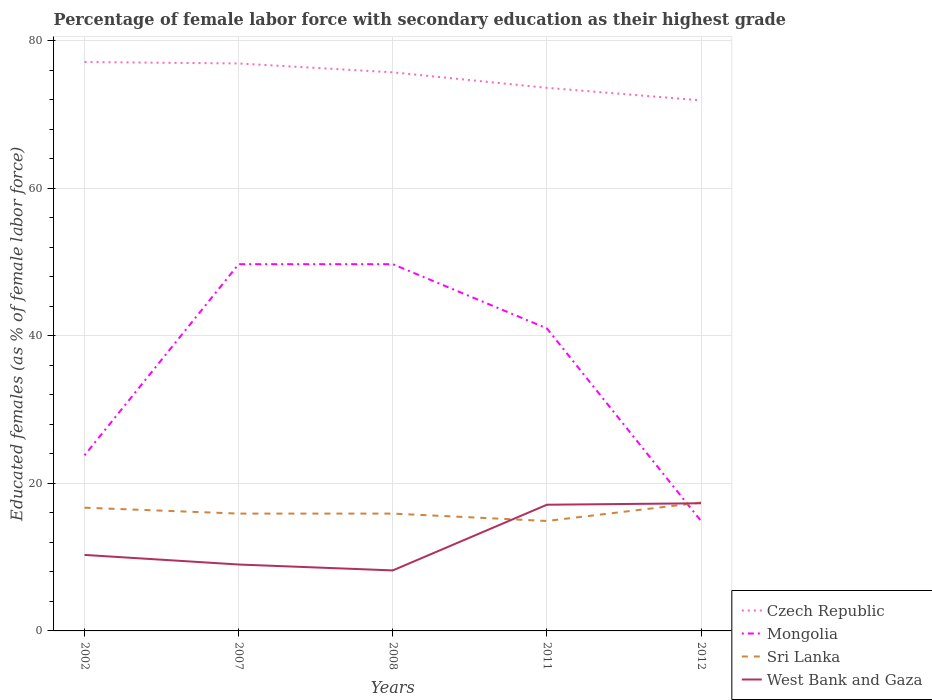Does the line corresponding to West Bank and Gaza intersect with the line corresponding to Mongolia?
Provide a short and direct response. Yes. Is the number of lines equal to the number of legend labels?
Make the answer very short. Yes. Across all years, what is the maximum percentage of female labor force with secondary education in Sri Lanka?
Offer a very short reply. 14.9. What is the total percentage of female labor force with secondary education in Mongolia in the graph?
Your response must be concise. 34.8. What is the difference between the highest and the second highest percentage of female labor force with secondary education in Mongolia?
Ensure brevity in your answer.  34.8. What is the difference between the highest and the lowest percentage of female labor force with secondary education in Mongolia?
Offer a terse response. 3. What is the difference between two consecutive major ticks on the Y-axis?
Keep it short and to the point. 20. Are the values on the major ticks of Y-axis written in scientific E-notation?
Give a very brief answer. No. Does the graph contain any zero values?
Keep it short and to the point. No. Does the graph contain grids?
Your answer should be compact. Yes. How are the legend labels stacked?
Your answer should be very brief. Vertical. What is the title of the graph?
Keep it short and to the point. Percentage of female labor force with secondary education as their highest grade. What is the label or title of the Y-axis?
Provide a short and direct response. Educated females (as % of female labor force). What is the Educated females (as % of female labor force) of Czech Republic in 2002?
Offer a terse response. 77.1. What is the Educated females (as % of female labor force) in Mongolia in 2002?
Offer a very short reply. 23.8. What is the Educated females (as % of female labor force) in Sri Lanka in 2002?
Offer a very short reply. 16.7. What is the Educated females (as % of female labor force) in West Bank and Gaza in 2002?
Keep it short and to the point. 10.3. What is the Educated females (as % of female labor force) in Czech Republic in 2007?
Offer a terse response. 76.9. What is the Educated females (as % of female labor force) in Mongolia in 2007?
Give a very brief answer. 49.7. What is the Educated females (as % of female labor force) in Sri Lanka in 2007?
Make the answer very short. 15.9. What is the Educated females (as % of female labor force) of West Bank and Gaza in 2007?
Your response must be concise. 9. What is the Educated females (as % of female labor force) of Czech Republic in 2008?
Give a very brief answer. 75.7. What is the Educated females (as % of female labor force) of Mongolia in 2008?
Your response must be concise. 49.7. What is the Educated females (as % of female labor force) of Sri Lanka in 2008?
Make the answer very short. 15.9. What is the Educated females (as % of female labor force) in West Bank and Gaza in 2008?
Provide a succinct answer. 8.2. What is the Educated females (as % of female labor force) of Czech Republic in 2011?
Your answer should be compact. 73.6. What is the Educated females (as % of female labor force) of Mongolia in 2011?
Your answer should be compact. 41. What is the Educated females (as % of female labor force) of Sri Lanka in 2011?
Ensure brevity in your answer.  14.9. What is the Educated females (as % of female labor force) in West Bank and Gaza in 2011?
Ensure brevity in your answer.  17.1. What is the Educated females (as % of female labor force) of Czech Republic in 2012?
Make the answer very short. 71.9. What is the Educated females (as % of female labor force) in Mongolia in 2012?
Provide a short and direct response. 14.9. What is the Educated females (as % of female labor force) in Sri Lanka in 2012?
Your answer should be very brief. 17.4. What is the Educated females (as % of female labor force) of West Bank and Gaza in 2012?
Your answer should be very brief. 17.3. Across all years, what is the maximum Educated females (as % of female labor force) of Czech Republic?
Your answer should be very brief. 77.1. Across all years, what is the maximum Educated females (as % of female labor force) of Mongolia?
Your answer should be compact. 49.7. Across all years, what is the maximum Educated females (as % of female labor force) of Sri Lanka?
Your answer should be compact. 17.4. Across all years, what is the maximum Educated females (as % of female labor force) of West Bank and Gaza?
Ensure brevity in your answer.  17.3. Across all years, what is the minimum Educated females (as % of female labor force) in Czech Republic?
Provide a succinct answer. 71.9. Across all years, what is the minimum Educated females (as % of female labor force) of Mongolia?
Provide a short and direct response. 14.9. Across all years, what is the minimum Educated females (as % of female labor force) in Sri Lanka?
Give a very brief answer. 14.9. Across all years, what is the minimum Educated females (as % of female labor force) of West Bank and Gaza?
Keep it short and to the point. 8.2. What is the total Educated females (as % of female labor force) in Czech Republic in the graph?
Provide a succinct answer. 375.2. What is the total Educated females (as % of female labor force) of Mongolia in the graph?
Your response must be concise. 179.1. What is the total Educated females (as % of female labor force) in Sri Lanka in the graph?
Your answer should be compact. 80.8. What is the total Educated females (as % of female labor force) of West Bank and Gaza in the graph?
Your answer should be compact. 61.9. What is the difference between the Educated females (as % of female labor force) of Mongolia in 2002 and that in 2007?
Provide a succinct answer. -25.9. What is the difference between the Educated females (as % of female labor force) in Mongolia in 2002 and that in 2008?
Make the answer very short. -25.9. What is the difference between the Educated females (as % of female labor force) of Mongolia in 2002 and that in 2011?
Ensure brevity in your answer.  -17.2. What is the difference between the Educated females (as % of female labor force) in West Bank and Gaza in 2002 and that in 2011?
Make the answer very short. -6.8. What is the difference between the Educated females (as % of female labor force) of Czech Republic in 2002 and that in 2012?
Offer a terse response. 5.2. What is the difference between the Educated females (as % of female labor force) of Mongolia in 2002 and that in 2012?
Provide a short and direct response. 8.9. What is the difference between the Educated females (as % of female labor force) of Mongolia in 2007 and that in 2008?
Provide a short and direct response. 0. What is the difference between the Educated females (as % of female labor force) in Sri Lanka in 2007 and that in 2008?
Give a very brief answer. 0. What is the difference between the Educated females (as % of female labor force) of Czech Republic in 2007 and that in 2011?
Your answer should be compact. 3.3. What is the difference between the Educated females (as % of female labor force) of Sri Lanka in 2007 and that in 2011?
Offer a very short reply. 1. What is the difference between the Educated females (as % of female labor force) in West Bank and Gaza in 2007 and that in 2011?
Offer a very short reply. -8.1. What is the difference between the Educated females (as % of female labor force) of Mongolia in 2007 and that in 2012?
Keep it short and to the point. 34.8. What is the difference between the Educated females (as % of female labor force) of West Bank and Gaza in 2007 and that in 2012?
Make the answer very short. -8.3. What is the difference between the Educated females (as % of female labor force) of Czech Republic in 2008 and that in 2011?
Offer a terse response. 2.1. What is the difference between the Educated females (as % of female labor force) in Sri Lanka in 2008 and that in 2011?
Offer a very short reply. 1. What is the difference between the Educated females (as % of female labor force) in Czech Republic in 2008 and that in 2012?
Give a very brief answer. 3.8. What is the difference between the Educated females (as % of female labor force) of Mongolia in 2008 and that in 2012?
Your answer should be very brief. 34.8. What is the difference between the Educated females (as % of female labor force) of Sri Lanka in 2008 and that in 2012?
Your answer should be compact. -1.5. What is the difference between the Educated females (as % of female labor force) in West Bank and Gaza in 2008 and that in 2012?
Give a very brief answer. -9.1. What is the difference between the Educated females (as % of female labor force) of Czech Republic in 2011 and that in 2012?
Your answer should be compact. 1.7. What is the difference between the Educated females (as % of female labor force) of Mongolia in 2011 and that in 2012?
Make the answer very short. 26.1. What is the difference between the Educated females (as % of female labor force) in Sri Lanka in 2011 and that in 2012?
Keep it short and to the point. -2.5. What is the difference between the Educated females (as % of female labor force) of West Bank and Gaza in 2011 and that in 2012?
Offer a terse response. -0.2. What is the difference between the Educated females (as % of female labor force) of Czech Republic in 2002 and the Educated females (as % of female labor force) of Mongolia in 2007?
Ensure brevity in your answer.  27.4. What is the difference between the Educated females (as % of female labor force) in Czech Republic in 2002 and the Educated females (as % of female labor force) in Sri Lanka in 2007?
Give a very brief answer. 61.2. What is the difference between the Educated females (as % of female labor force) of Czech Republic in 2002 and the Educated females (as % of female labor force) of West Bank and Gaza in 2007?
Provide a short and direct response. 68.1. What is the difference between the Educated females (as % of female labor force) in Mongolia in 2002 and the Educated females (as % of female labor force) in Sri Lanka in 2007?
Your answer should be compact. 7.9. What is the difference between the Educated females (as % of female labor force) in Mongolia in 2002 and the Educated females (as % of female labor force) in West Bank and Gaza in 2007?
Provide a succinct answer. 14.8. What is the difference between the Educated females (as % of female labor force) in Czech Republic in 2002 and the Educated females (as % of female labor force) in Mongolia in 2008?
Make the answer very short. 27.4. What is the difference between the Educated females (as % of female labor force) of Czech Republic in 2002 and the Educated females (as % of female labor force) of Sri Lanka in 2008?
Make the answer very short. 61.2. What is the difference between the Educated females (as % of female labor force) of Czech Republic in 2002 and the Educated females (as % of female labor force) of West Bank and Gaza in 2008?
Your answer should be very brief. 68.9. What is the difference between the Educated females (as % of female labor force) of Mongolia in 2002 and the Educated females (as % of female labor force) of Sri Lanka in 2008?
Your answer should be compact. 7.9. What is the difference between the Educated females (as % of female labor force) of Czech Republic in 2002 and the Educated females (as % of female labor force) of Mongolia in 2011?
Your response must be concise. 36.1. What is the difference between the Educated females (as % of female labor force) in Czech Republic in 2002 and the Educated females (as % of female labor force) in Sri Lanka in 2011?
Your response must be concise. 62.2. What is the difference between the Educated females (as % of female labor force) in Czech Republic in 2002 and the Educated females (as % of female labor force) in West Bank and Gaza in 2011?
Offer a very short reply. 60. What is the difference between the Educated females (as % of female labor force) of Mongolia in 2002 and the Educated females (as % of female labor force) of Sri Lanka in 2011?
Offer a very short reply. 8.9. What is the difference between the Educated females (as % of female labor force) of Sri Lanka in 2002 and the Educated females (as % of female labor force) of West Bank and Gaza in 2011?
Your answer should be compact. -0.4. What is the difference between the Educated females (as % of female labor force) of Czech Republic in 2002 and the Educated females (as % of female labor force) of Mongolia in 2012?
Offer a very short reply. 62.2. What is the difference between the Educated females (as % of female labor force) in Czech Republic in 2002 and the Educated females (as % of female labor force) in Sri Lanka in 2012?
Your answer should be very brief. 59.7. What is the difference between the Educated females (as % of female labor force) in Czech Republic in 2002 and the Educated females (as % of female labor force) in West Bank and Gaza in 2012?
Your response must be concise. 59.8. What is the difference between the Educated females (as % of female labor force) of Sri Lanka in 2002 and the Educated females (as % of female labor force) of West Bank and Gaza in 2012?
Ensure brevity in your answer.  -0.6. What is the difference between the Educated females (as % of female labor force) in Czech Republic in 2007 and the Educated females (as % of female labor force) in Mongolia in 2008?
Your response must be concise. 27.2. What is the difference between the Educated females (as % of female labor force) of Czech Republic in 2007 and the Educated females (as % of female labor force) of Sri Lanka in 2008?
Make the answer very short. 61. What is the difference between the Educated females (as % of female labor force) in Czech Republic in 2007 and the Educated females (as % of female labor force) in West Bank and Gaza in 2008?
Your response must be concise. 68.7. What is the difference between the Educated females (as % of female labor force) in Mongolia in 2007 and the Educated females (as % of female labor force) in Sri Lanka in 2008?
Your answer should be very brief. 33.8. What is the difference between the Educated females (as % of female labor force) of Mongolia in 2007 and the Educated females (as % of female labor force) of West Bank and Gaza in 2008?
Your answer should be very brief. 41.5. What is the difference between the Educated females (as % of female labor force) of Sri Lanka in 2007 and the Educated females (as % of female labor force) of West Bank and Gaza in 2008?
Ensure brevity in your answer.  7.7. What is the difference between the Educated females (as % of female labor force) of Czech Republic in 2007 and the Educated females (as % of female labor force) of Mongolia in 2011?
Provide a succinct answer. 35.9. What is the difference between the Educated females (as % of female labor force) in Czech Republic in 2007 and the Educated females (as % of female labor force) in West Bank and Gaza in 2011?
Offer a terse response. 59.8. What is the difference between the Educated females (as % of female labor force) in Mongolia in 2007 and the Educated females (as % of female labor force) in Sri Lanka in 2011?
Keep it short and to the point. 34.8. What is the difference between the Educated females (as % of female labor force) in Mongolia in 2007 and the Educated females (as % of female labor force) in West Bank and Gaza in 2011?
Your answer should be compact. 32.6. What is the difference between the Educated females (as % of female labor force) of Czech Republic in 2007 and the Educated females (as % of female labor force) of Mongolia in 2012?
Your answer should be compact. 62. What is the difference between the Educated females (as % of female labor force) in Czech Republic in 2007 and the Educated females (as % of female labor force) in Sri Lanka in 2012?
Your response must be concise. 59.5. What is the difference between the Educated females (as % of female labor force) in Czech Republic in 2007 and the Educated females (as % of female labor force) in West Bank and Gaza in 2012?
Offer a terse response. 59.6. What is the difference between the Educated females (as % of female labor force) in Mongolia in 2007 and the Educated females (as % of female labor force) in Sri Lanka in 2012?
Make the answer very short. 32.3. What is the difference between the Educated females (as % of female labor force) in Mongolia in 2007 and the Educated females (as % of female labor force) in West Bank and Gaza in 2012?
Give a very brief answer. 32.4. What is the difference between the Educated females (as % of female labor force) in Czech Republic in 2008 and the Educated females (as % of female labor force) in Mongolia in 2011?
Provide a short and direct response. 34.7. What is the difference between the Educated females (as % of female labor force) in Czech Republic in 2008 and the Educated females (as % of female labor force) in Sri Lanka in 2011?
Ensure brevity in your answer.  60.8. What is the difference between the Educated females (as % of female labor force) of Czech Republic in 2008 and the Educated females (as % of female labor force) of West Bank and Gaza in 2011?
Give a very brief answer. 58.6. What is the difference between the Educated females (as % of female labor force) in Mongolia in 2008 and the Educated females (as % of female labor force) in Sri Lanka in 2011?
Your answer should be compact. 34.8. What is the difference between the Educated females (as % of female labor force) in Mongolia in 2008 and the Educated females (as % of female labor force) in West Bank and Gaza in 2011?
Offer a very short reply. 32.6. What is the difference between the Educated females (as % of female labor force) in Sri Lanka in 2008 and the Educated females (as % of female labor force) in West Bank and Gaza in 2011?
Provide a short and direct response. -1.2. What is the difference between the Educated females (as % of female labor force) of Czech Republic in 2008 and the Educated females (as % of female labor force) of Mongolia in 2012?
Your answer should be compact. 60.8. What is the difference between the Educated females (as % of female labor force) in Czech Republic in 2008 and the Educated females (as % of female labor force) in Sri Lanka in 2012?
Give a very brief answer. 58.3. What is the difference between the Educated females (as % of female labor force) of Czech Republic in 2008 and the Educated females (as % of female labor force) of West Bank and Gaza in 2012?
Offer a very short reply. 58.4. What is the difference between the Educated females (as % of female labor force) in Mongolia in 2008 and the Educated females (as % of female labor force) in Sri Lanka in 2012?
Provide a succinct answer. 32.3. What is the difference between the Educated females (as % of female labor force) in Mongolia in 2008 and the Educated females (as % of female labor force) in West Bank and Gaza in 2012?
Ensure brevity in your answer.  32.4. What is the difference between the Educated females (as % of female labor force) of Sri Lanka in 2008 and the Educated females (as % of female labor force) of West Bank and Gaza in 2012?
Offer a terse response. -1.4. What is the difference between the Educated females (as % of female labor force) in Czech Republic in 2011 and the Educated females (as % of female labor force) in Mongolia in 2012?
Give a very brief answer. 58.7. What is the difference between the Educated females (as % of female labor force) of Czech Republic in 2011 and the Educated females (as % of female labor force) of Sri Lanka in 2012?
Your response must be concise. 56.2. What is the difference between the Educated females (as % of female labor force) in Czech Republic in 2011 and the Educated females (as % of female labor force) in West Bank and Gaza in 2012?
Give a very brief answer. 56.3. What is the difference between the Educated females (as % of female labor force) in Mongolia in 2011 and the Educated females (as % of female labor force) in Sri Lanka in 2012?
Give a very brief answer. 23.6. What is the difference between the Educated females (as % of female labor force) of Mongolia in 2011 and the Educated females (as % of female labor force) of West Bank and Gaza in 2012?
Give a very brief answer. 23.7. What is the average Educated females (as % of female labor force) in Czech Republic per year?
Provide a succinct answer. 75.04. What is the average Educated females (as % of female labor force) in Mongolia per year?
Your response must be concise. 35.82. What is the average Educated females (as % of female labor force) of Sri Lanka per year?
Your answer should be very brief. 16.16. What is the average Educated females (as % of female labor force) of West Bank and Gaza per year?
Provide a succinct answer. 12.38. In the year 2002, what is the difference between the Educated females (as % of female labor force) of Czech Republic and Educated females (as % of female labor force) of Mongolia?
Your answer should be compact. 53.3. In the year 2002, what is the difference between the Educated females (as % of female labor force) in Czech Republic and Educated females (as % of female labor force) in Sri Lanka?
Provide a short and direct response. 60.4. In the year 2002, what is the difference between the Educated females (as % of female labor force) in Czech Republic and Educated females (as % of female labor force) in West Bank and Gaza?
Your answer should be compact. 66.8. In the year 2002, what is the difference between the Educated females (as % of female labor force) of Mongolia and Educated females (as % of female labor force) of West Bank and Gaza?
Your response must be concise. 13.5. In the year 2002, what is the difference between the Educated females (as % of female labor force) in Sri Lanka and Educated females (as % of female labor force) in West Bank and Gaza?
Provide a succinct answer. 6.4. In the year 2007, what is the difference between the Educated females (as % of female labor force) in Czech Republic and Educated females (as % of female labor force) in Mongolia?
Your response must be concise. 27.2. In the year 2007, what is the difference between the Educated females (as % of female labor force) in Czech Republic and Educated females (as % of female labor force) in West Bank and Gaza?
Ensure brevity in your answer.  67.9. In the year 2007, what is the difference between the Educated females (as % of female labor force) in Mongolia and Educated females (as % of female labor force) in Sri Lanka?
Make the answer very short. 33.8. In the year 2007, what is the difference between the Educated females (as % of female labor force) in Mongolia and Educated females (as % of female labor force) in West Bank and Gaza?
Offer a terse response. 40.7. In the year 2008, what is the difference between the Educated females (as % of female labor force) in Czech Republic and Educated females (as % of female labor force) in Sri Lanka?
Your answer should be compact. 59.8. In the year 2008, what is the difference between the Educated females (as % of female labor force) of Czech Republic and Educated females (as % of female labor force) of West Bank and Gaza?
Keep it short and to the point. 67.5. In the year 2008, what is the difference between the Educated females (as % of female labor force) in Mongolia and Educated females (as % of female labor force) in Sri Lanka?
Your answer should be very brief. 33.8. In the year 2008, what is the difference between the Educated females (as % of female labor force) in Mongolia and Educated females (as % of female labor force) in West Bank and Gaza?
Your response must be concise. 41.5. In the year 2008, what is the difference between the Educated females (as % of female labor force) of Sri Lanka and Educated females (as % of female labor force) of West Bank and Gaza?
Provide a short and direct response. 7.7. In the year 2011, what is the difference between the Educated females (as % of female labor force) of Czech Republic and Educated females (as % of female labor force) of Mongolia?
Your answer should be very brief. 32.6. In the year 2011, what is the difference between the Educated females (as % of female labor force) in Czech Republic and Educated females (as % of female labor force) in Sri Lanka?
Offer a terse response. 58.7. In the year 2011, what is the difference between the Educated females (as % of female labor force) in Czech Republic and Educated females (as % of female labor force) in West Bank and Gaza?
Offer a terse response. 56.5. In the year 2011, what is the difference between the Educated females (as % of female labor force) of Mongolia and Educated females (as % of female labor force) of Sri Lanka?
Make the answer very short. 26.1. In the year 2011, what is the difference between the Educated females (as % of female labor force) in Mongolia and Educated females (as % of female labor force) in West Bank and Gaza?
Make the answer very short. 23.9. In the year 2012, what is the difference between the Educated females (as % of female labor force) in Czech Republic and Educated females (as % of female labor force) in Mongolia?
Provide a succinct answer. 57. In the year 2012, what is the difference between the Educated females (as % of female labor force) in Czech Republic and Educated females (as % of female labor force) in Sri Lanka?
Give a very brief answer. 54.5. In the year 2012, what is the difference between the Educated females (as % of female labor force) of Czech Republic and Educated females (as % of female labor force) of West Bank and Gaza?
Offer a terse response. 54.6. What is the ratio of the Educated females (as % of female labor force) in Mongolia in 2002 to that in 2007?
Keep it short and to the point. 0.48. What is the ratio of the Educated females (as % of female labor force) of Sri Lanka in 2002 to that in 2007?
Offer a very short reply. 1.05. What is the ratio of the Educated females (as % of female labor force) of West Bank and Gaza in 2002 to that in 2007?
Your answer should be compact. 1.14. What is the ratio of the Educated females (as % of female labor force) of Czech Republic in 2002 to that in 2008?
Provide a succinct answer. 1.02. What is the ratio of the Educated females (as % of female labor force) of Mongolia in 2002 to that in 2008?
Offer a very short reply. 0.48. What is the ratio of the Educated females (as % of female labor force) of Sri Lanka in 2002 to that in 2008?
Your answer should be compact. 1.05. What is the ratio of the Educated females (as % of female labor force) in West Bank and Gaza in 2002 to that in 2008?
Ensure brevity in your answer.  1.26. What is the ratio of the Educated females (as % of female labor force) in Czech Republic in 2002 to that in 2011?
Your answer should be very brief. 1.05. What is the ratio of the Educated females (as % of female labor force) of Mongolia in 2002 to that in 2011?
Your answer should be compact. 0.58. What is the ratio of the Educated females (as % of female labor force) in Sri Lanka in 2002 to that in 2011?
Your response must be concise. 1.12. What is the ratio of the Educated females (as % of female labor force) of West Bank and Gaza in 2002 to that in 2011?
Your answer should be very brief. 0.6. What is the ratio of the Educated females (as % of female labor force) in Czech Republic in 2002 to that in 2012?
Your answer should be compact. 1.07. What is the ratio of the Educated females (as % of female labor force) of Mongolia in 2002 to that in 2012?
Your response must be concise. 1.6. What is the ratio of the Educated females (as % of female labor force) of Sri Lanka in 2002 to that in 2012?
Your answer should be compact. 0.96. What is the ratio of the Educated females (as % of female labor force) of West Bank and Gaza in 2002 to that in 2012?
Your answer should be very brief. 0.6. What is the ratio of the Educated females (as % of female labor force) in Czech Republic in 2007 to that in 2008?
Your answer should be very brief. 1.02. What is the ratio of the Educated females (as % of female labor force) in Mongolia in 2007 to that in 2008?
Make the answer very short. 1. What is the ratio of the Educated females (as % of female labor force) in West Bank and Gaza in 2007 to that in 2008?
Ensure brevity in your answer.  1.1. What is the ratio of the Educated females (as % of female labor force) in Czech Republic in 2007 to that in 2011?
Your answer should be very brief. 1.04. What is the ratio of the Educated females (as % of female labor force) in Mongolia in 2007 to that in 2011?
Provide a short and direct response. 1.21. What is the ratio of the Educated females (as % of female labor force) of Sri Lanka in 2007 to that in 2011?
Your answer should be very brief. 1.07. What is the ratio of the Educated females (as % of female labor force) of West Bank and Gaza in 2007 to that in 2011?
Ensure brevity in your answer.  0.53. What is the ratio of the Educated females (as % of female labor force) in Czech Republic in 2007 to that in 2012?
Your answer should be very brief. 1.07. What is the ratio of the Educated females (as % of female labor force) of Mongolia in 2007 to that in 2012?
Your answer should be very brief. 3.34. What is the ratio of the Educated females (as % of female labor force) in Sri Lanka in 2007 to that in 2012?
Your answer should be very brief. 0.91. What is the ratio of the Educated females (as % of female labor force) in West Bank and Gaza in 2007 to that in 2012?
Offer a terse response. 0.52. What is the ratio of the Educated females (as % of female labor force) in Czech Republic in 2008 to that in 2011?
Your response must be concise. 1.03. What is the ratio of the Educated females (as % of female labor force) of Mongolia in 2008 to that in 2011?
Offer a terse response. 1.21. What is the ratio of the Educated females (as % of female labor force) in Sri Lanka in 2008 to that in 2011?
Ensure brevity in your answer.  1.07. What is the ratio of the Educated females (as % of female labor force) of West Bank and Gaza in 2008 to that in 2011?
Keep it short and to the point. 0.48. What is the ratio of the Educated females (as % of female labor force) of Czech Republic in 2008 to that in 2012?
Offer a very short reply. 1.05. What is the ratio of the Educated females (as % of female labor force) in Mongolia in 2008 to that in 2012?
Ensure brevity in your answer.  3.34. What is the ratio of the Educated females (as % of female labor force) in Sri Lanka in 2008 to that in 2012?
Make the answer very short. 0.91. What is the ratio of the Educated females (as % of female labor force) in West Bank and Gaza in 2008 to that in 2012?
Offer a very short reply. 0.47. What is the ratio of the Educated females (as % of female labor force) in Czech Republic in 2011 to that in 2012?
Give a very brief answer. 1.02. What is the ratio of the Educated females (as % of female labor force) in Mongolia in 2011 to that in 2012?
Ensure brevity in your answer.  2.75. What is the ratio of the Educated females (as % of female labor force) in Sri Lanka in 2011 to that in 2012?
Provide a succinct answer. 0.86. What is the ratio of the Educated females (as % of female labor force) of West Bank and Gaza in 2011 to that in 2012?
Ensure brevity in your answer.  0.99. What is the difference between the highest and the second highest Educated females (as % of female labor force) of Czech Republic?
Offer a very short reply. 0.2. What is the difference between the highest and the lowest Educated females (as % of female labor force) in Czech Republic?
Your answer should be very brief. 5.2. What is the difference between the highest and the lowest Educated females (as % of female labor force) of Mongolia?
Your answer should be very brief. 34.8. What is the difference between the highest and the lowest Educated females (as % of female labor force) of West Bank and Gaza?
Offer a terse response. 9.1. 